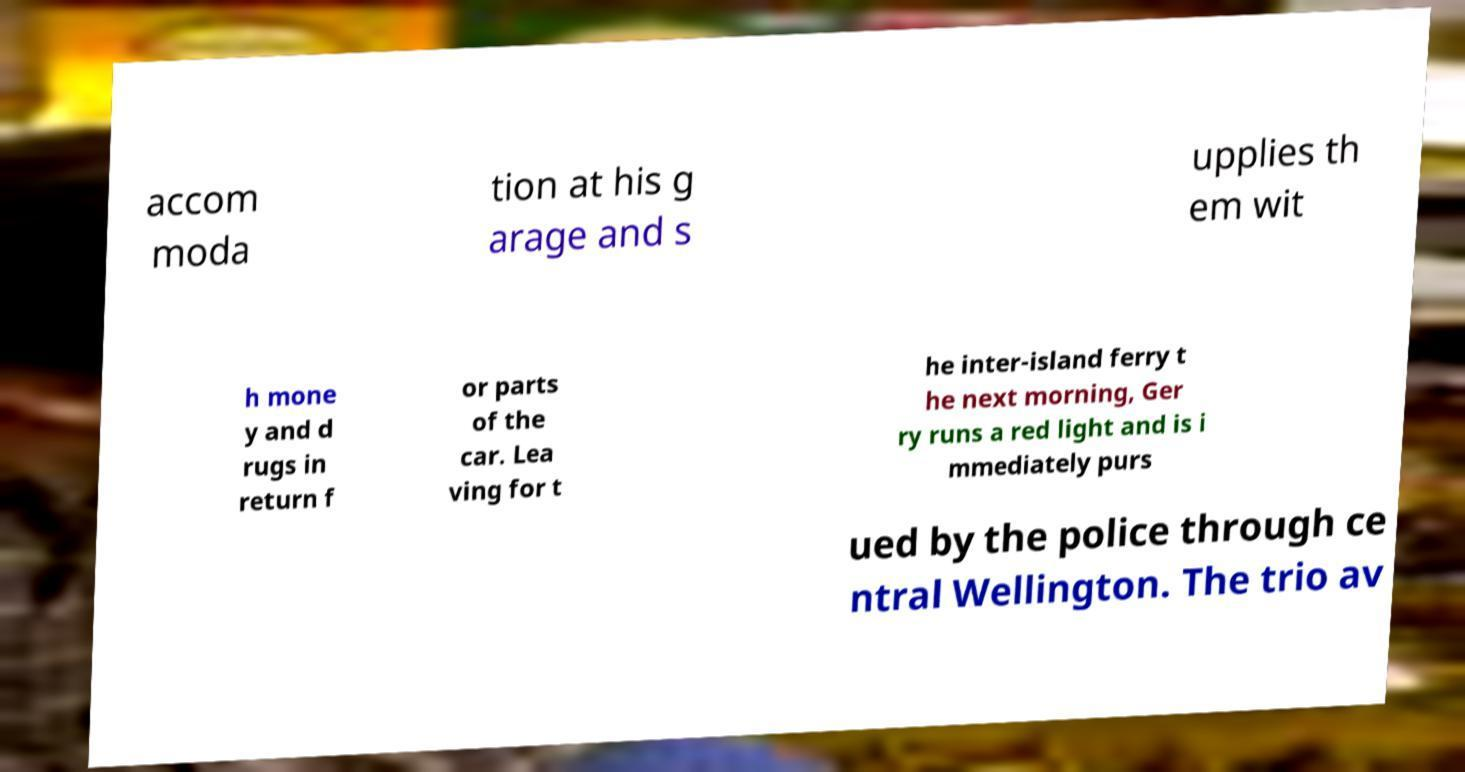For documentation purposes, I need the text within this image transcribed. Could you provide that? accom moda tion at his g arage and s upplies th em wit h mone y and d rugs in return f or parts of the car. Lea ving for t he inter-island ferry t he next morning, Ger ry runs a red light and is i mmediately purs ued by the police through ce ntral Wellington. The trio av 